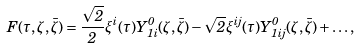Convert formula to latex. <formula><loc_0><loc_0><loc_500><loc_500>F ( \tau , \zeta , \bar { \zeta } ) = \frac { \sqrt { 2 } } { 2 } \xi ^ { i } ( \tau ) Y _ { 1 i } ^ { 0 } ( \zeta , \bar { \zeta } ) - \sqrt { 2 } \xi ^ { i j } ( \tau ) Y _ { 1 i j } ^ { 0 } ( \zeta , \bar { \zeta } ) + \dots ,</formula> 